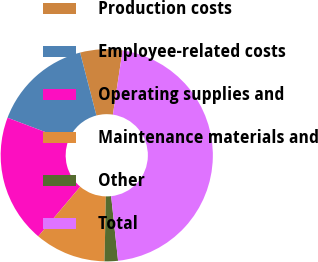Convert chart. <chart><loc_0><loc_0><loc_500><loc_500><pie_chart><fcel>Production costs<fcel>Employee-related costs<fcel>Operating supplies and<fcel>Maintenance materials and<fcel>Other<fcel>Total<nl><fcel>6.43%<fcel>15.2%<fcel>19.59%<fcel>10.82%<fcel>2.04%<fcel>45.91%<nl></chart> 